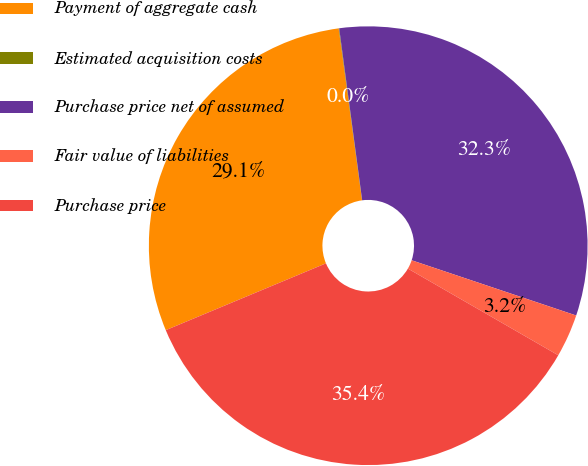<chart> <loc_0><loc_0><loc_500><loc_500><pie_chart><fcel>Payment of aggregate cash<fcel>Estimated acquisition costs<fcel>Purchase price net of assumed<fcel>Fair value of liabilities<fcel>Purchase price<nl><fcel>29.14%<fcel>0.04%<fcel>32.27%<fcel>3.17%<fcel>35.39%<nl></chart> 